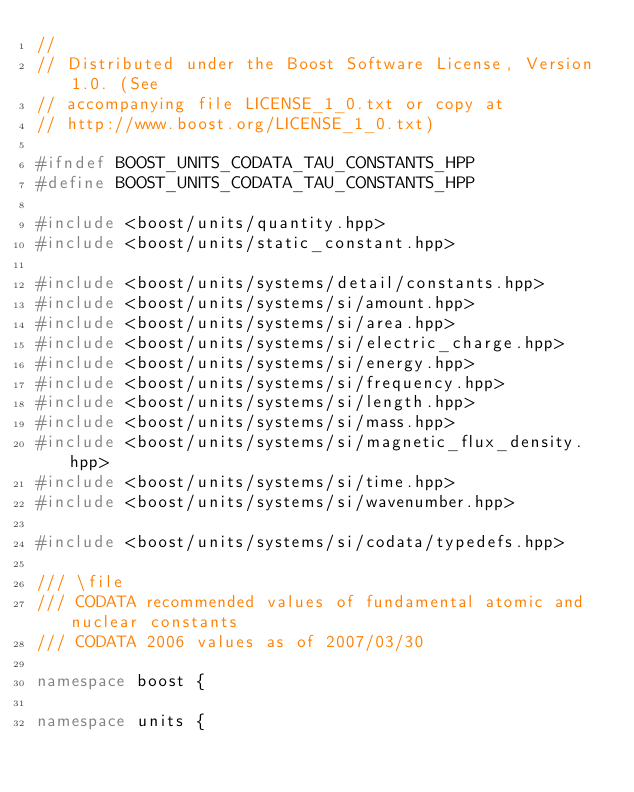Convert code to text. <code><loc_0><loc_0><loc_500><loc_500><_C++_>//
// Distributed under the Boost Software License, Version 1.0. (See
// accompanying file LICENSE_1_0.txt or copy at
// http://www.boost.org/LICENSE_1_0.txt)

#ifndef BOOST_UNITS_CODATA_TAU_CONSTANTS_HPP
#define BOOST_UNITS_CODATA_TAU_CONSTANTS_HPP

#include <boost/units/quantity.hpp>
#include <boost/units/static_constant.hpp>

#include <boost/units/systems/detail/constants.hpp>
#include <boost/units/systems/si/amount.hpp>
#include <boost/units/systems/si/area.hpp>
#include <boost/units/systems/si/electric_charge.hpp>
#include <boost/units/systems/si/energy.hpp>
#include <boost/units/systems/si/frequency.hpp>
#include <boost/units/systems/si/length.hpp>
#include <boost/units/systems/si/mass.hpp>
#include <boost/units/systems/si/magnetic_flux_density.hpp>
#include <boost/units/systems/si/time.hpp>
#include <boost/units/systems/si/wavenumber.hpp>

#include <boost/units/systems/si/codata/typedefs.hpp>

/// \file
/// CODATA recommended values of fundamental atomic and nuclear constants
/// CODATA 2006 values as of 2007/03/30

namespace boost {

namespace units { 
</code> 